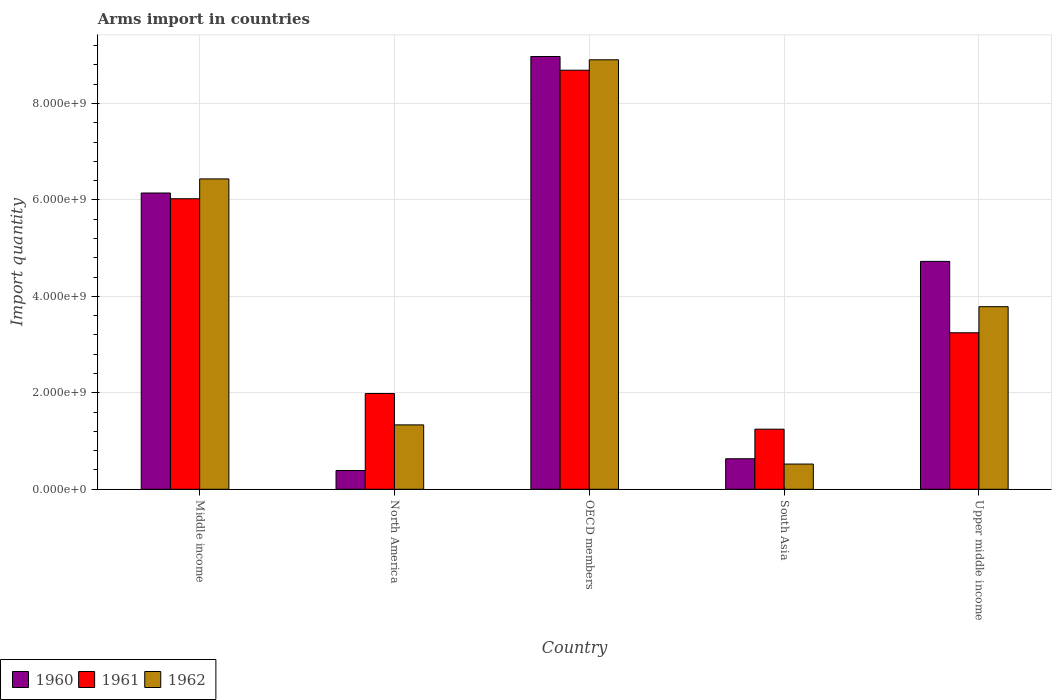How many groups of bars are there?
Give a very brief answer. 5. What is the total arms import in 1962 in North America?
Provide a short and direct response. 1.34e+09. Across all countries, what is the maximum total arms import in 1960?
Your answer should be compact. 8.97e+09. Across all countries, what is the minimum total arms import in 1961?
Offer a terse response. 1.25e+09. In which country was the total arms import in 1962 maximum?
Your answer should be compact. OECD members. In which country was the total arms import in 1961 minimum?
Offer a terse response. South Asia. What is the total total arms import in 1960 in the graph?
Your answer should be very brief. 2.09e+1. What is the difference between the total arms import in 1961 in Middle income and that in North America?
Provide a succinct answer. 4.04e+09. What is the difference between the total arms import in 1962 in OECD members and the total arms import in 1960 in Middle income?
Your answer should be compact. 2.76e+09. What is the average total arms import in 1960 per country?
Offer a very short reply. 4.17e+09. What is the difference between the total arms import of/in 1962 and total arms import of/in 1960 in OECD members?
Your answer should be very brief. -6.80e+07. In how many countries, is the total arms import in 1962 greater than 3600000000?
Keep it short and to the point. 3. What is the ratio of the total arms import in 1961 in North America to that in Upper middle income?
Your answer should be compact. 0.61. Is the difference between the total arms import in 1962 in North America and OECD members greater than the difference between the total arms import in 1960 in North America and OECD members?
Provide a short and direct response. Yes. What is the difference between the highest and the second highest total arms import in 1962?
Provide a succinct answer. 5.12e+09. What is the difference between the highest and the lowest total arms import in 1962?
Provide a succinct answer. 8.38e+09. What does the 1st bar from the left in Middle income represents?
Your answer should be very brief. 1960. Is it the case that in every country, the sum of the total arms import in 1962 and total arms import in 1961 is greater than the total arms import in 1960?
Ensure brevity in your answer.  Yes. Are all the bars in the graph horizontal?
Provide a succinct answer. No. Are the values on the major ticks of Y-axis written in scientific E-notation?
Ensure brevity in your answer.  Yes. Where does the legend appear in the graph?
Your response must be concise. Bottom left. What is the title of the graph?
Your answer should be compact. Arms import in countries. Does "1960" appear as one of the legend labels in the graph?
Offer a terse response. Yes. What is the label or title of the Y-axis?
Give a very brief answer. Import quantity. What is the Import quantity of 1960 in Middle income?
Your answer should be compact. 6.14e+09. What is the Import quantity of 1961 in Middle income?
Give a very brief answer. 6.02e+09. What is the Import quantity in 1962 in Middle income?
Make the answer very short. 6.44e+09. What is the Import quantity in 1960 in North America?
Your answer should be compact. 3.89e+08. What is the Import quantity in 1961 in North America?
Ensure brevity in your answer.  1.98e+09. What is the Import quantity of 1962 in North America?
Make the answer very short. 1.34e+09. What is the Import quantity of 1960 in OECD members?
Your answer should be compact. 8.97e+09. What is the Import quantity of 1961 in OECD members?
Provide a short and direct response. 8.69e+09. What is the Import quantity of 1962 in OECD members?
Offer a very short reply. 8.90e+09. What is the Import quantity in 1960 in South Asia?
Provide a succinct answer. 6.33e+08. What is the Import quantity in 1961 in South Asia?
Provide a short and direct response. 1.25e+09. What is the Import quantity in 1962 in South Asia?
Keep it short and to the point. 5.23e+08. What is the Import quantity of 1960 in Upper middle income?
Provide a short and direct response. 4.72e+09. What is the Import quantity in 1961 in Upper middle income?
Offer a terse response. 3.24e+09. What is the Import quantity in 1962 in Upper middle income?
Offer a terse response. 3.79e+09. Across all countries, what is the maximum Import quantity of 1960?
Your answer should be compact. 8.97e+09. Across all countries, what is the maximum Import quantity of 1961?
Keep it short and to the point. 8.69e+09. Across all countries, what is the maximum Import quantity of 1962?
Give a very brief answer. 8.90e+09. Across all countries, what is the minimum Import quantity of 1960?
Provide a short and direct response. 3.89e+08. Across all countries, what is the minimum Import quantity in 1961?
Offer a terse response. 1.25e+09. Across all countries, what is the minimum Import quantity of 1962?
Make the answer very short. 5.23e+08. What is the total Import quantity of 1960 in the graph?
Your response must be concise. 2.09e+1. What is the total Import quantity of 1961 in the graph?
Make the answer very short. 2.12e+1. What is the total Import quantity in 1962 in the graph?
Ensure brevity in your answer.  2.10e+1. What is the difference between the Import quantity of 1960 in Middle income and that in North America?
Offer a terse response. 5.75e+09. What is the difference between the Import quantity in 1961 in Middle income and that in North America?
Offer a very short reply. 4.04e+09. What is the difference between the Import quantity of 1962 in Middle income and that in North America?
Offer a very short reply. 5.10e+09. What is the difference between the Import quantity of 1960 in Middle income and that in OECD members?
Provide a succinct answer. -2.83e+09. What is the difference between the Import quantity in 1961 in Middle income and that in OECD members?
Your answer should be compact. -2.66e+09. What is the difference between the Import quantity of 1962 in Middle income and that in OECD members?
Your answer should be compact. -2.47e+09. What is the difference between the Import quantity in 1960 in Middle income and that in South Asia?
Make the answer very short. 5.51e+09. What is the difference between the Import quantity in 1961 in Middle income and that in South Asia?
Offer a very short reply. 4.78e+09. What is the difference between the Import quantity in 1962 in Middle income and that in South Asia?
Ensure brevity in your answer.  5.91e+09. What is the difference between the Import quantity in 1960 in Middle income and that in Upper middle income?
Your answer should be very brief. 1.42e+09. What is the difference between the Import quantity of 1961 in Middle income and that in Upper middle income?
Offer a very short reply. 2.78e+09. What is the difference between the Import quantity in 1962 in Middle income and that in Upper middle income?
Your answer should be very brief. 2.65e+09. What is the difference between the Import quantity of 1960 in North America and that in OECD members?
Make the answer very short. -8.58e+09. What is the difference between the Import quantity in 1961 in North America and that in OECD members?
Provide a short and direct response. -6.70e+09. What is the difference between the Import quantity of 1962 in North America and that in OECD members?
Offer a terse response. -7.57e+09. What is the difference between the Import quantity of 1960 in North America and that in South Asia?
Offer a terse response. -2.44e+08. What is the difference between the Import quantity of 1961 in North America and that in South Asia?
Offer a very short reply. 7.39e+08. What is the difference between the Import quantity in 1962 in North America and that in South Asia?
Your response must be concise. 8.12e+08. What is the difference between the Import quantity of 1960 in North America and that in Upper middle income?
Provide a short and direct response. -4.34e+09. What is the difference between the Import quantity in 1961 in North America and that in Upper middle income?
Make the answer very short. -1.26e+09. What is the difference between the Import quantity of 1962 in North America and that in Upper middle income?
Offer a very short reply. -2.45e+09. What is the difference between the Import quantity in 1960 in OECD members and that in South Asia?
Ensure brevity in your answer.  8.34e+09. What is the difference between the Import quantity in 1961 in OECD members and that in South Asia?
Your answer should be compact. 7.44e+09. What is the difference between the Import quantity in 1962 in OECD members and that in South Asia?
Your answer should be compact. 8.38e+09. What is the difference between the Import quantity in 1960 in OECD members and that in Upper middle income?
Ensure brevity in your answer.  4.25e+09. What is the difference between the Import quantity in 1961 in OECD members and that in Upper middle income?
Ensure brevity in your answer.  5.44e+09. What is the difference between the Import quantity in 1962 in OECD members and that in Upper middle income?
Offer a very short reply. 5.12e+09. What is the difference between the Import quantity of 1960 in South Asia and that in Upper middle income?
Offer a terse response. -4.09e+09. What is the difference between the Import quantity of 1961 in South Asia and that in Upper middle income?
Offer a very short reply. -2.00e+09. What is the difference between the Import quantity in 1962 in South Asia and that in Upper middle income?
Give a very brief answer. -3.26e+09. What is the difference between the Import quantity in 1960 in Middle income and the Import quantity in 1961 in North America?
Provide a short and direct response. 4.16e+09. What is the difference between the Import quantity in 1960 in Middle income and the Import quantity in 1962 in North America?
Provide a succinct answer. 4.81e+09. What is the difference between the Import quantity of 1961 in Middle income and the Import quantity of 1962 in North America?
Your answer should be very brief. 4.69e+09. What is the difference between the Import quantity in 1960 in Middle income and the Import quantity in 1961 in OECD members?
Your answer should be very brief. -2.55e+09. What is the difference between the Import quantity in 1960 in Middle income and the Import quantity in 1962 in OECD members?
Your answer should be very brief. -2.76e+09. What is the difference between the Import quantity of 1961 in Middle income and the Import quantity of 1962 in OECD members?
Ensure brevity in your answer.  -2.88e+09. What is the difference between the Import quantity of 1960 in Middle income and the Import quantity of 1961 in South Asia?
Keep it short and to the point. 4.90e+09. What is the difference between the Import quantity in 1960 in Middle income and the Import quantity in 1962 in South Asia?
Provide a succinct answer. 5.62e+09. What is the difference between the Import quantity of 1961 in Middle income and the Import quantity of 1962 in South Asia?
Your response must be concise. 5.50e+09. What is the difference between the Import quantity in 1960 in Middle income and the Import quantity in 1961 in Upper middle income?
Ensure brevity in your answer.  2.90e+09. What is the difference between the Import quantity in 1960 in Middle income and the Import quantity in 1962 in Upper middle income?
Offer a terse response. 2.36e+09. What is the difference between the Import quantity of 1961 in Middle income and the Import quantity of 1962 in Upper middle income?
Ensure brevity in your answer.  2.24e+09. What is the difference between the Import quantity of 1960 in North America and the Import quantity of 1961 in OECD members?
Your answer should be compact. -8.30e+09. What is the difference between the Import quantity in 1960 in North America and the Import quantity in 1962 in OECD members?
Offer a terse response. -8.52e+09. What is the difference between the Import quantity of 1961 in North America and the Import quantity of 1962 in OECD members?
Your response must be concise. -6.92e+09. What is the difference between the Import quantity in 1960 in North America and the Import quantity in 1961 in South Asia?
Provide a succinct answer. -8.57e+08. What is the difference between the Import quantity of 1960 in North America and the Import quantity of 1962 in South Asia?
Your answer should be very brief. -1.34e+08. What is the difference between the Import quantity in 1961 in North America and the Import quantity in 1962 in South Asia?
Give a very brief answer. 1.46e+09. What is the difference between the Import quantity of 1960 in North America and the Import quantity of 1961 in Upper middle income?
Provide a succinct answer. -2.86e+09. What is the difference between the Import quantity in 1960 in North America and the Import quantity in 1962 in Upper middle income?
Make the answer very short. -3.40e+09. What is the difference between the Import quantity of 1961 in North America and the Import quantity of 1962 in Upper middle income?
Offer a very short reply. -1.80e+09. What is the difference between the Import quantity of 1960 in OECD members and the Import quantity of 1961 in South Asia?
Keep it short and to the point. 7.73e+09. What is the difference between the Import quantity of 1960 in OECD members and the Import quantity of 1962 in South Asia?
Provide a succinct answer. 8.45e+09. What is the difference between the Import quantity of 1961 in OECD members and the Import quantity of 1962 in South Asia?
Provide a succinct answer. 8.17e+09. What is the difference between the Import quantity in 1960 in OECD members and the Import quantity in 1961 in Upper middle income?
Your answer should be compact. 5.73e+09. What is the difference between the Import quantity in 1960 in OECD members and the Import quantity in 1962 in Upper middle income?
Offer a terse response. 5.19e+09. What is the difference between the Import quantity in 1961 in OECD members and the Import quantity in 1962 in Upper middle income?
Provide a short and direct response. 4.90e+09. What is the difference between the Import quantity of 1960 in South Asia and the Import quantity of 1961 in Upper middle income?
Your response must be concise. -2.61e+09. What is the difference between the Import quantity of 1960 in South Asia and the Import quantity of 1962 in Upper middle income?
Make the answer very short. -3.15e+09. What is the difference between the Import quantity of 1961 in South Asia and the Import quantity of 1962 in Upper middle income?
Give a very brief answer. -2.54e+09. What is the average Import quantity of 1960 per country?
Your response must be concise. 4.17e+09. What is the average Import quantity in 1961 per country?
Provide a succinct answer. 4.24e+09. What is the average Import quantity of 1962 per country?
Give a very brief answer. 4.20e+09. What is the difference between the Import quantity of 1960 and Import quantity of 1961 in Middle income?
Your response must be concise. 1.19e+08. What is the difference between the Import quantity in 1960 and Import quantity in 1962 in Middle income?
Provide a succinct answer. -2.92e+08. What is the difference between the Import quantity of 1961 and Import quantity of 1962 in Middle income?
Provide a short and direct response. -4.11e+08. What is the difference between the Import quantity of 1960 and Import quantity of 1961 in North America?
Ensure brevity in your answer.  -1.60e+09. What is the difference between the Import quantity of 1960 and Import quantity of 1962 in North America?
Offer a very short reply. -9.46e+08. What is the difference between the Import quantity of 1961 and Import quantity of 1962 in North America?
Offer a very short reply. 6.50e+08. What is the difference between the Import quantity of 1960 and Import quantity of 1961 in OECD members?
Give a very brief answer. 2.84e+08. What is the difference between the Import quantity of 1960 and Import quantity of 1962 in OECD members?
Offer a terse response. 6.80e+07. What is the difference between the Import quantity of 1961 and Import quantity of 1962 in OECD members?
Your response must be concise. -2.16e+08. What is the difference between the Import quantity of 1960 and Import quantity of 1961 in South Asia?
Your response must be concise. -6.13e+08. What is the difference between the Import quantity in 1960 and Import quantity in 1962 in South Asia?
Ensure brevity in your answer.  1.10e+08. What is the difference between the Import quantity of 1961 and Import quantity of 1962 in South Asia?
Give a very brief answer. 7.23e+08. What is the difference between the Import quantity in 1960 and Import quantity in 1961 in Upper middle income?
Provide a succinct answer. 1.48e+09. What is the difference between the Import quantity in 1960 and Import quantity in 1962 in Upper middle income?
Keep it short and to the point. 9.39e+08. What is the difference between the Import quantity of 1961 and Import quantity of 1962 in Upper middle income?
Keep it short and to the point. -5.41e+08. What is the ratio of the Import quantity of 1960 in Middle income to that in North America?
Provide a succinct answer. 15.79. What is the ratio of the Import quantity of 1961 in Middle income to that in North America?
Offer a very short reply. 3.03. What is the ratio of the Import quantity of 1962 in Middle income to that in North America?
Ensure brevity in your answer.  4.82. What is the ratio of the Import quantity of 1960 in Middle income to that in OECD members?
Make the answer very short. 0.68. What is the ratio of the Import quantity in 1961 in Middle income to that in OECD members?
Provide a short and direct response. 0.69. What is the ratio of the Import quantity of 1962 in Middle income to that in OECD members?
Offer a very short reply. 0.72. What is the ratio of the Import quantity of 1960 in Middle income to that in South Asia?
Your answer should be very brief. 9.7. What is the ratio of the Import quantity in 1961 in Middle income to that in South Asia?
Your answer should be compact. 4.83. What is the ratio of the Import quantity in 1962 in Middle income to that in South Asia?
Provide a short and direct response. 12.3. What is the ratio of the Import quantity of 1960 in Middle income to that in Upper middle income?
Give a very brief answer. 1.3. What is the ratio of the Import quantity in 1961 in Middle income to that in Upper middle income?
Make the answer very short. 1.86. What is the ratio of the Import quantity in 1962 in Middle income to that in Upper middle income?
Give a very brief answer. 1.7. What is the ratio of the Import quantity of 1960 in North America to that in OECD members?
Offer a very short reply. 0.04. What is the ratio of the Import quantity in 1961 in North America to that in OECD members?
Make the answer very short. 0.23. What is the ratio of the Import quantity of 1962 in North America to that in OECD members?
Give a very brief answer. 0.15. What is the ratio of the Import quantity in 1960 in North America to that in South Asia?
Ensure brevity in your answer.  0.61. What is the ratio of the Import quantity of 1961 in North America to that in South Asia?
Your answer should be compact. 1.59. What is the ratio of the Import quantity in 1962 in North America to that in South Asia?
Your response must be concise. 2.55. What is the ratio of the Import quantity of 1960 in North America to that in Upper middle income?
Your response must be concise. 0.08. What is the ratio of the Import quantity in 1961 in North America to that in Upper middle income?
Your answer should be compact. 0.61. What is the ratio of the Import quantity of 1962 in North America to that in Upper middle income?
Provide a short and direct response. 0.35. What is the ratio of the Import quantity of 1960 in OECD members to that in South Asia?
Make the answer very short. 14.18. What is the ratio of the Import quantity of 1961 in OECD members to that in South Asia?
Ensure brevity in your answer.  6.97. What is the ratio of the Import quantity of 1962 in OECD members to that in South Asia?
Your answer should be compact. 17.03. What is the ratio of the Import quantity in 1960 in OECD members to that in Upper middle income?
Keep it short and to the point. 1.9. What is the ratio of the Import quantity in 1961 in OECD members to that in Upper middle income?
Your answer should be compact. 2.68. What is the ratio of the Import quantity of 1962 in OECD members to that in Upper middle income?
Make the answer very short. 2.35. What is the ratio of the Import quantity in 1960 in South Asia to that in Upper middle income?
Offer a terse response. 0.13. What is the ratio of the Import quantity in 1961 in South Asia to that in Upper middle income?
Ensure brevity in your answer.  0.38. What is the ratio of the Import quantity of 1962 in South Asia to that in Upper middle income?
Offer a terse response. 0.14. What is the difference between the highest and the second highest Import quantity in 1960?
Your answer should be very brief. 2.83e+09. What is the difference between the highest and the second highest Import quantity of 1961?
Offer a very short reply. 2.66e+09. What is the difference between the highest and the second highest Import quantity in 1962?
Make the answer very short. 2.47e+09. What is the difference between the highest and the lowest Import quantity in 1960?
Make the answer very short. 8.58e+09. What is the difference between the highest and the lowest Import quantity of 1961?
Keep it short and to the point. 7.44e+09. What is the difference between the highest and the lowest Import quantity of 1962?
Make the answer very short. 8.38e+09. 